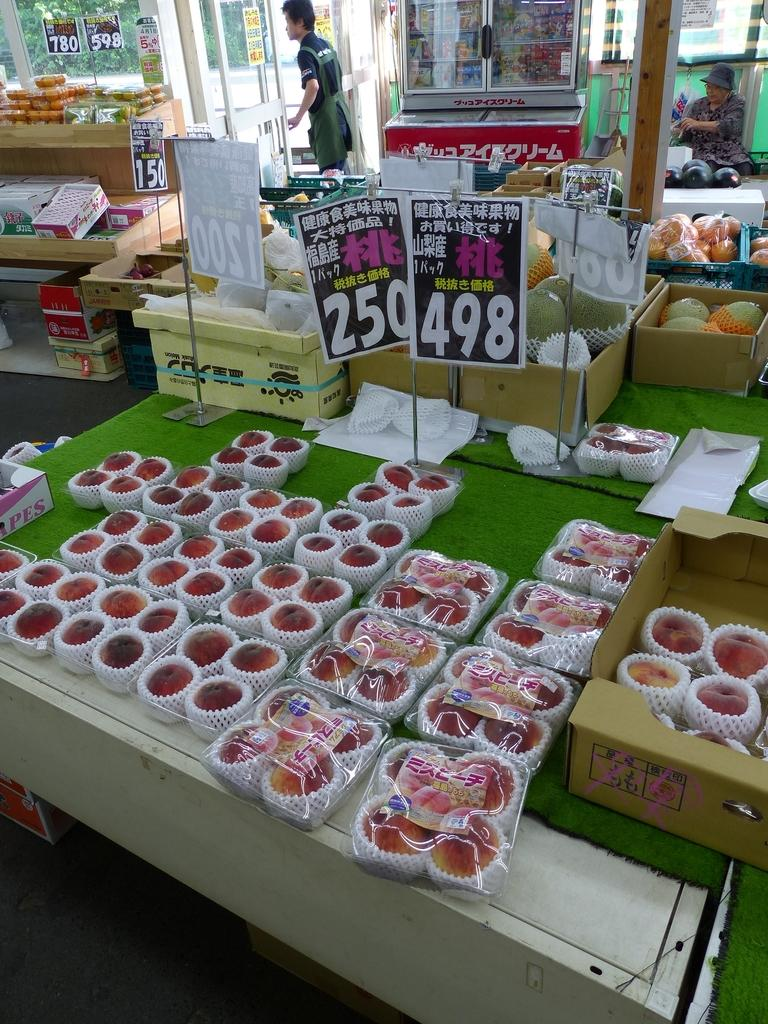<image>
Offer a succinct explanation of the picture presented. Apples are for sale in an Asian market for 498 